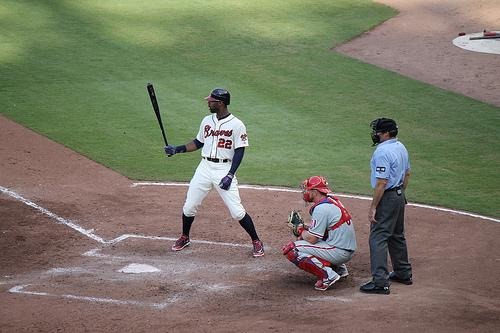Give a concise description of the primary occurrence and the individuals involved in the image. The image captures a pivotal baseball game instance, with the batter, catcher, and umpire at the center of the action. Explain the main happening in the picture and the people participating in it. The picture captures a significant moment in a baseball match, including a player holding a bat, a catcher, and an umpire. Give a brief account of the principal incident and the characters involved in the snapshot. The snapshot captures an intense baseball match situation, where a player holding a bat, a catcher, and an umpire are the main characters. Detail the central event and the main characters involved in the picture. A batter holding a baseball bat, alongside a catcher and an umpire, are the focal points of the intense game play captured in the image. Write a short statement summarizing the primary event and individuals in the photo. The photo depicts a baseball game with a batter, catcher, and umpire actively engaged in a play. Mention the central activity in the picture and the primary figures involved in it. In the picture, a batter is getting ready to hit the ball, with the catcher and umpire observing the game. Describe the key scene and characters in the image. The image showcases a crucial moment in a baseball game, featuring a batter, a catcher, and an umpire. Offer a succinct description of the primary scenario and people engaged in the image. The image emphasizes a vital point in a baseball game, as it focuses on a batter, a catcher, and an umpire. Summarize the main activity and the key figures involved in that moment in the photo. The photo highlights a critical point in a baseball game, featuring a batter, a catcher, and an umpire in the midst of action. Provide a brief description of the main action happening in the image. A baseball player is holding a bat and preparing to swing, while the catcher and umpire watch behind him. 